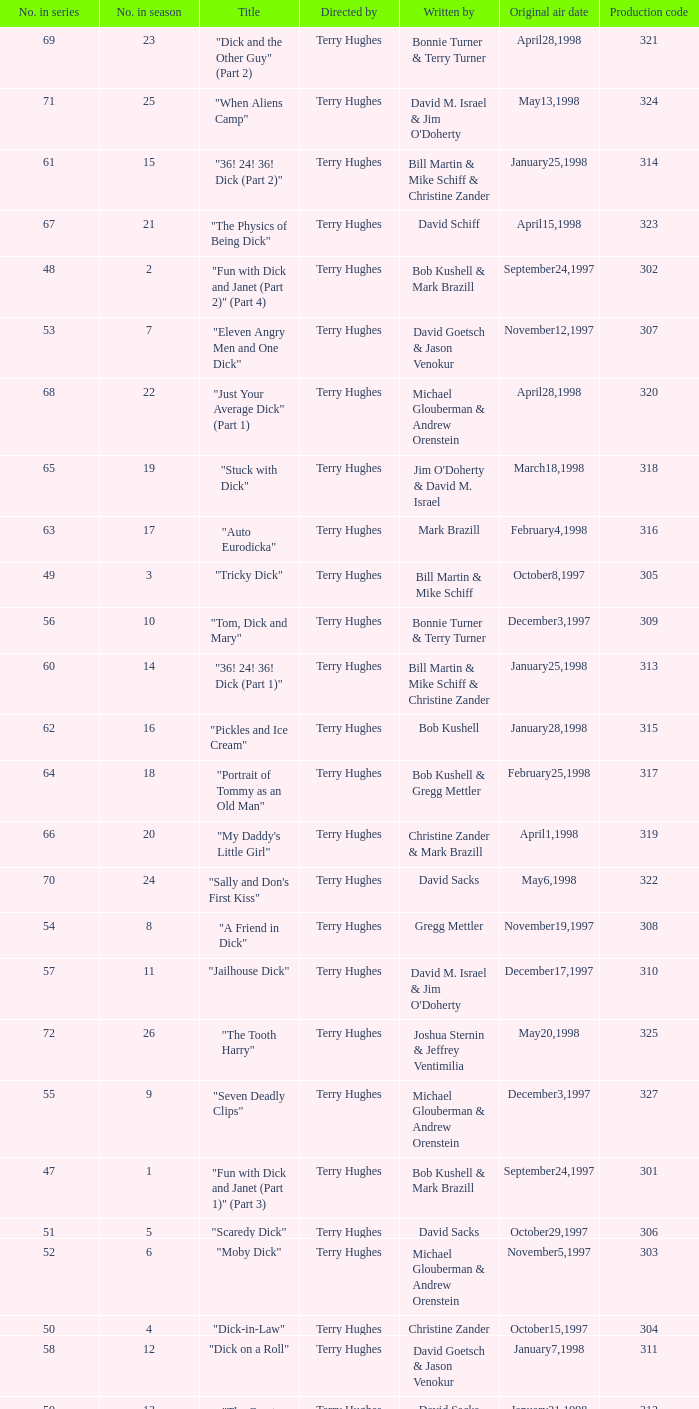Who were the writers of the episode titled "Tricky Dick"? Bill Martin & Mike Schiff. 